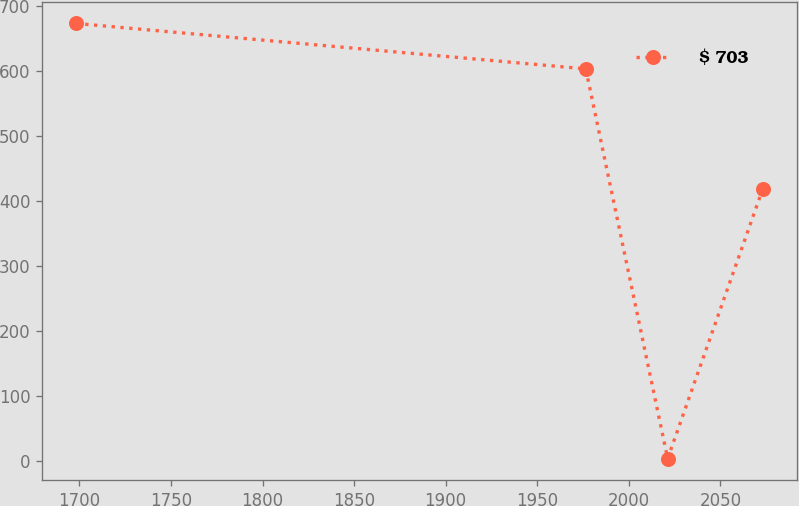<chart> <loc_0><loc_0><loc_500><loc_500><line_chart><ecel><fcel>$ 703<nl><fcel>1698.37<fcel>673.18<nl><fcel>1976.5<fcel>603.4<nl><fcel>2021.22<fcel>4.45<nl><fcel>2073.14<fcel>418.92<nl></chart> 